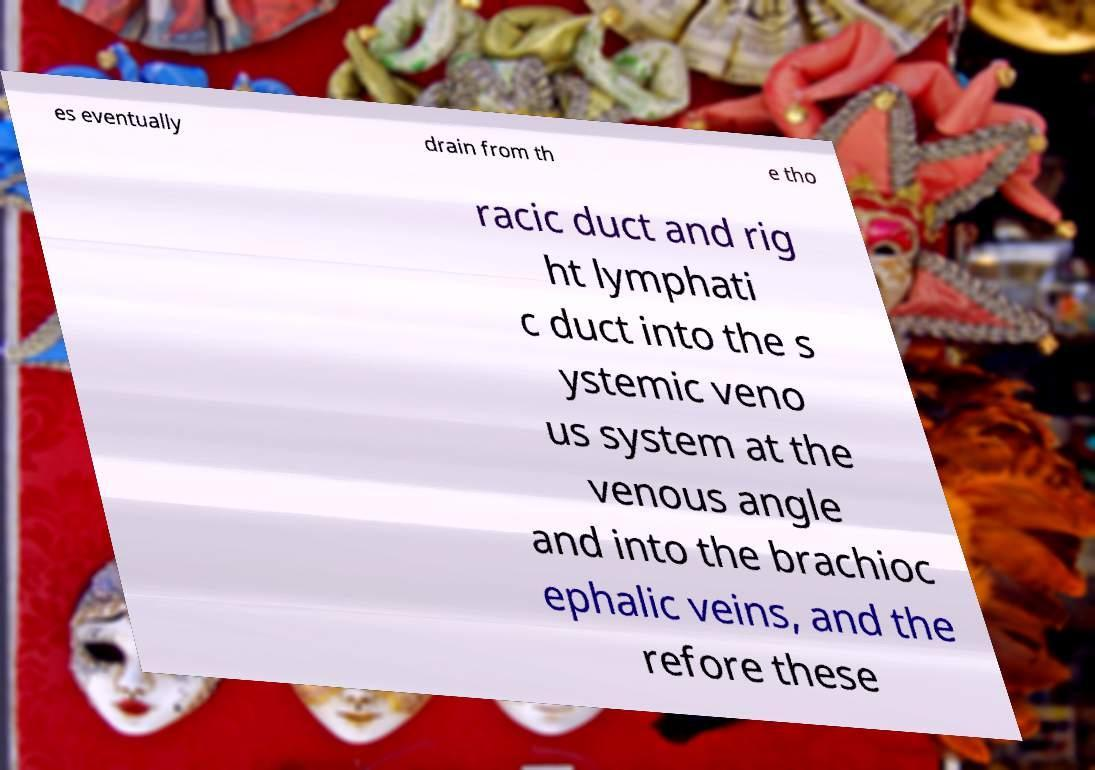Can you accurately transcribe the text from the provided image for me? es eventually drain from th e tho racic duct and rig ht lymphati c duct into the s ystemic veno us system at the venous angle and into the brachioc ephalic veins, and the refore these 